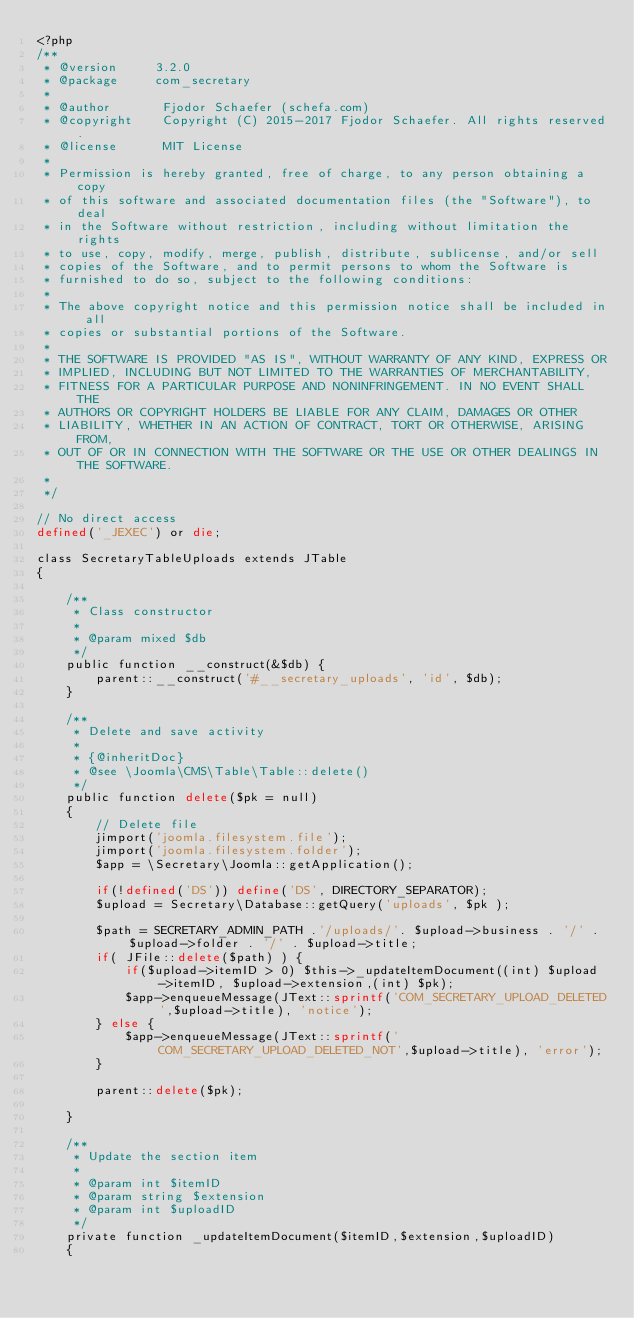Convert code to text. <code><loc_0><loc_0><loc_500><loc_500><_PHP_><?php
/**
 * @version     3.2.0
 * @package     com_secretary
 *
 * @author       Fjodor Schaefer (schefa.com)
 * @copyright    Copyright (C) 2015-2017 Fjodor Schaefer. All rights reserved.
 * @license      MIT License
 * 
 * Permission is hereby granted, free of charge, to any person obtaining a copy
 * of this software and associated documentation files (the "Software"), to deal
 * in the Software without restriction, including without limitation the rights
 * to use, copy, modify, merge, publish, distribute, sublicense, and/or sell
 * copies of the Software, and to permit persons to whom the Software is
 * furnished to do so, subject to the following conditions:
 * 
 * The above copyright notice and this permission notice shall be included in all
 * copies or substantial portions of the Software.
 * 
 * THE SOFTWARE IS PROVIDED "AS IS", WITHOUT WARRANTY OF ANY KIND, EXPRESS OR
 * IMPLIED, INCLUDING BUT NOT LIMITED TO THE WARRANTIES OF MERCHANTABILITY,
 * FITNESS FOR A PARTICULAR PURPOSE AND NONINFRINGEMENT. IN NO EVENT SHALL THE
 * AUTHORS OR COPYRIGHT HOLDERS BE LIABLE FOR ANY CLAIM, DAMAGES OR OTHER
 * LIABILITY, WHETHER IN AN ACTION OF CONTRACT, TORT OR OTHERWISE, ARISING FROM,
 * OUT OF OR IN CONNECTION WITH THE SOFTWARE OR THE USE OR OTHER DEALINGS IN THE SOFTWARE.
 * 
 */
 
// No direct access
defined('_JEXEC') or die;

class SecretaryTableUploads extends JTable
{
    
    /**
     * Class constructor
     *
     * @param mixed $db
     */
    public function __construct(&$db) {
        parent::__construct('#__secretary_uploads', 'id', $db);
    }
    
    /**
     * Delete and save activity
     *
     * {@inheritDoc}
     * @see \Joomla\CMS\Table\Table::delete()
     */
	public function delete($pk = null)
	{
		// Delete file
		jimport('joomla.filesystem.file');
		jimport('joomla.filesystem.folder');
		$app = \Secretary\Joomla::getApplication();
		
		if(!defined('DS')) define('DS', DIRECTORY_SEPARATOR);
		$upload = Secretary\Database::getQuery('uploads', $pk );
		
		$path = SECRETARY_ADMIN_PATH .'/uploads/'. $upload->business . '/' . $upload->folder . '/' . $upload->title;
		if( JFile::delete($path) ) {
		    if($upload->itemID > 0) $this->_updateItemDocument((int) $upload->itemID, $upload->extension,(int) $pk);
		    $app->enqueueMessage(JText::sprintf('COM_SECRETARY_UPLOAD_DELETED',$upload->title), 'notice');
		} else {
		    $app->enqueueMessage(JText::sprintf('COM_SECRETARY_UPLOAD_DELETED_NOT',$upload->title), 'error');
		}
		
		parent::delete($pk);
		
	}
	
	/**
	 * Update the section item
	 * 
	 * @param int $itemID
	 * @param string $extension
	 * @param int $uploadID
	 */
	private function _updateItemDocument($itemID,$extension,$uploadID)
	{</code> 